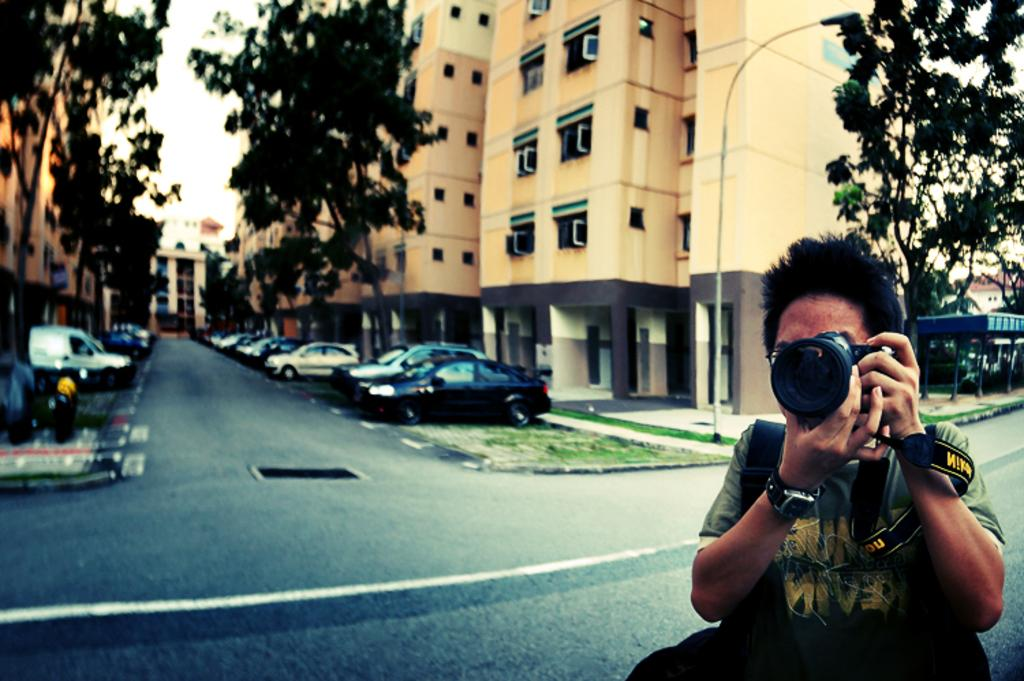What is the man in the image doing? The man is capturing photographs. What can be seen in the background of the image? There is a building, trees, the sky, and vehicles in the background of the image. How many oranges can be seen in the grip of the man's hand in the image? There are no oranges present in the image, and the man's hand is not visible. 